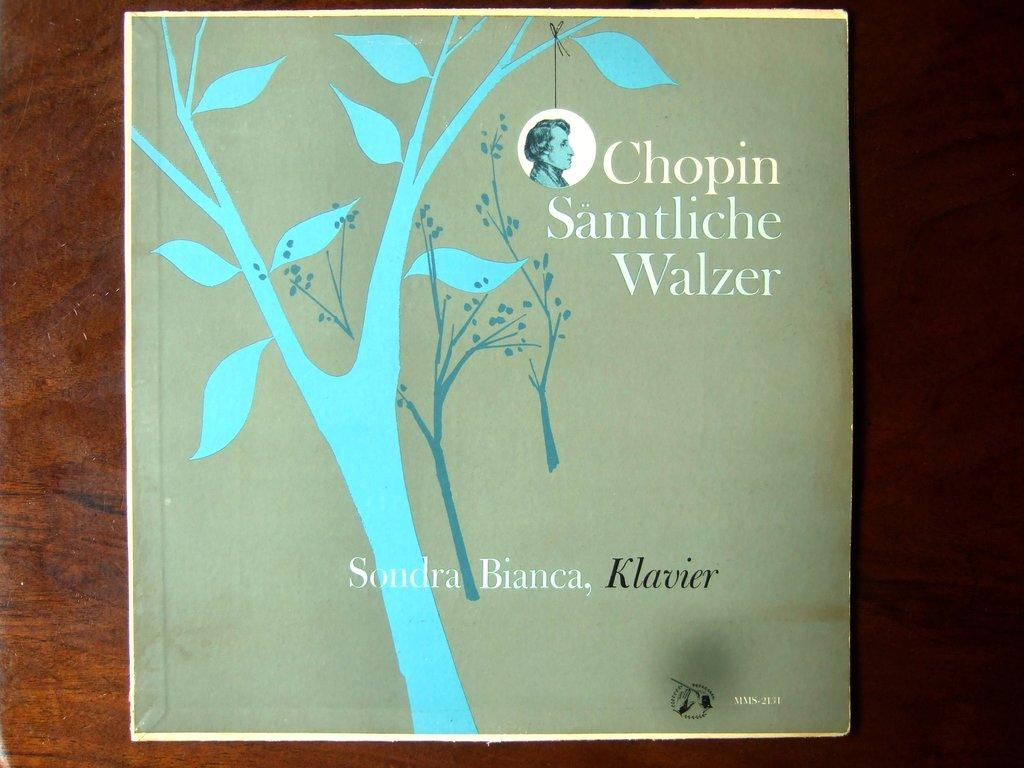Provide a one-sentence caption for the provided image. A Chopin album is illustrated with minimalist artwork of trees. 